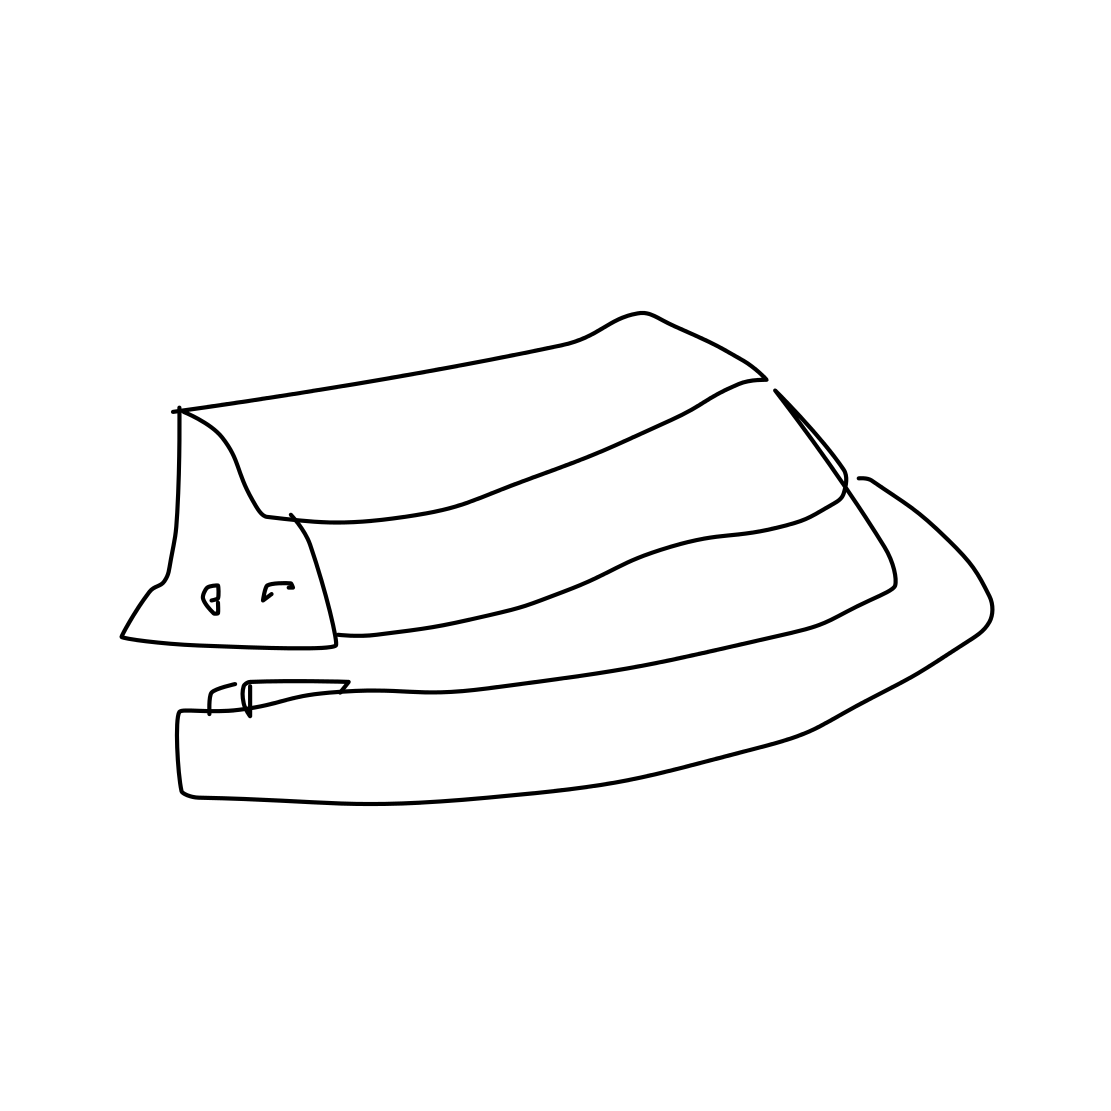What occasions might this type of hat be worn for? This type of hat could be worn for various occasions ranging from daily wear for a touch of elegance to special events like weddings, period-themed parties, or by performers in a jazz band. 